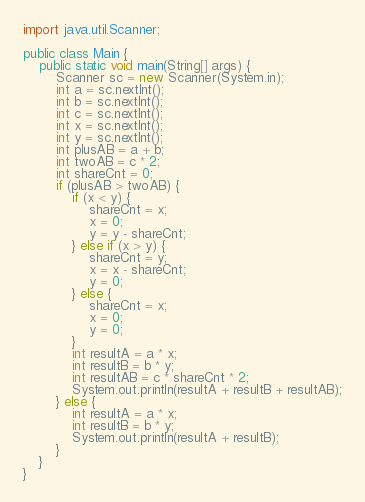<code> <loc_0><loc_0><loc_500><loc_500><_Java_>import java.util.Scanner;

public class Main {
	public static void main(String[] args) {
		Scanner sc = new Scanner(System.in);
		int a = sc.nextInt();
		int b = sc.nextInt();
		int c = sc.nextInt();
		int x = sc.nextInt();
		int y = sc.nextInt();
		int plusAB = a + b;
		int twoAB = c * 2;
		int shareCnt = 0;
		if (plusAB > twoAB) {
			if (x < y) {
				shareCnt = x;
				x = 0;
				y = y - shareCnt;
			} else if (x > y) {
				shareCnt = y;
				x = x - shareCnt;
				y = 0;
			} else {
				shareCnt = x;
				x = 0;
				y = 0;
			}
			int resultA = a * x;
			int resultB = b * y;
			int resultAB = c * shareCnt * 2;
			System.out.println(resultA + resultB + resultAB);
		} else {
			int resultA = a * x;
			int resultB = b * y;
			System.out.println(resultA + resultB);
		}
	}
}</code> 